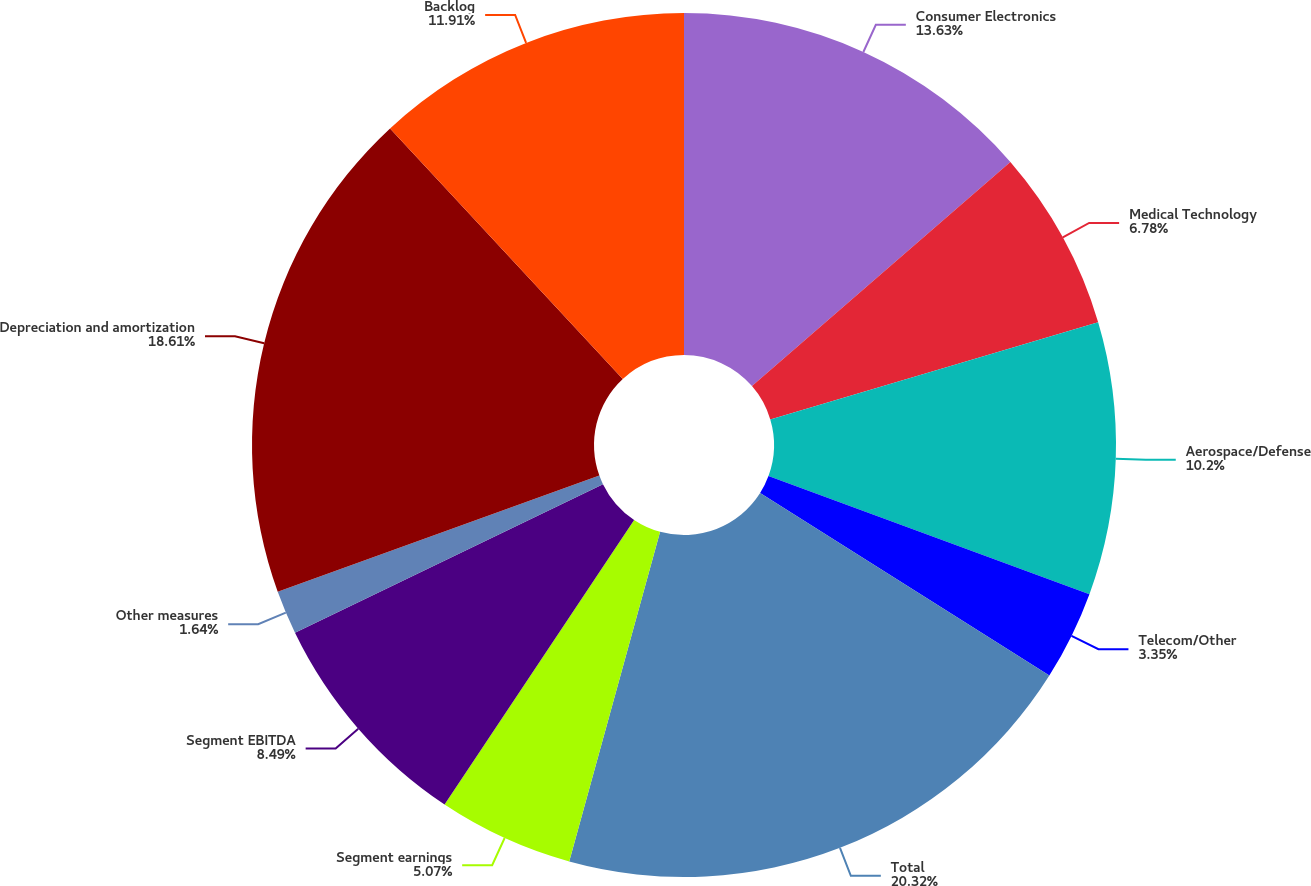Convert chart. <chart><loc_0><loc_0><loc_500><loc_500><pie_chart><fcel>Consumer Electronics<fcel>Medical Technology<fcel>Aerospace/Defense<fcel>Telecom/Other<fcel>Total<fcel>Segment earnings<fcel>Segment EBITDA<fcel>Other measures<fcel>Depreciation and amortization<fcel>Backlog<nl><fcel>13.63%<fcel>6.78%<fcel>10.2%<fcel>3.35%<fcel>20.32%<fcel>5.07%<fcel>8.49%<fcel>1.64%<fcel>18.61%<fcel>11.91%<nl></chart> 